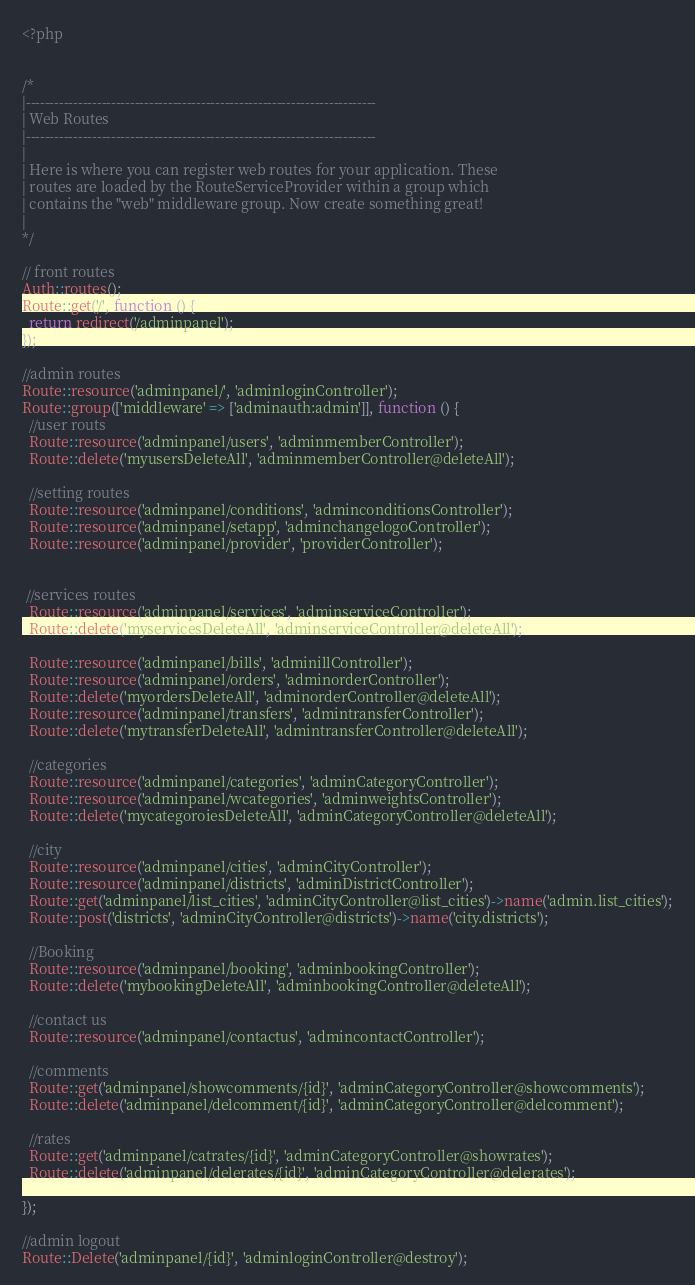<code> <loc_0><loc_0><loc_500><loc_500><_PHP_><?php


/*
|--------------------------------------------------------------------------
| Web Routes
|--------------------------------------------------------------------------
|
| Here is where you can register web routes for your application. These
| routes are loaded by the RouteServiceProvider within a group which
| contains the "web" middleware group. Now create something great!
|
*/

// front routes
Auth::routes();
Route::get('/', function () {
  return redirect('/adminpanel');
});

//admin routes
Route::resource('adminpanel/', 'adminloginController');
Route::group(['middleware' => ['adminauth:admin']], function () {
  //user routs
  Route::resource('adminpanel/users', 'adminmemberController');
  Route::delete('myusersDeleteAll', 'adminmemberController@deleteAll');

  //setting routes
  Route::resource('adminpanel/conditions', 'adminconditionsController');
  Route::resource('adminpanel/setapp', 'adminchangelogoController');
  Route::resource('adminpanel/provider', 'providerController');


 //services routes
  Route::resource('adminpanel/services', 'adminserviceController');
  Route::delete('myservicesDeleteAll', 'adminserviceController@deleteAll');

  Route::resource('adminpanel/bills', 'adminillController');
  Route::resource('adminpanel/orders', 'adminorderController');
  Route::delete('myordersDeleteAll', 'adminorderController@deleteAll');
  Route::resource('adminpanel/transfers', 'admintransferController');
  Route::delete('mytransferDeleteAll', 'admintransferController@deleteAll');

  //categories
  Route::resource('adminpanel/categories', 'adminCategoryController');
  Route::resource('adminpanel/wcategories', 'adminweightsController');
  Route::delete('mycategoroiesDeleteAll', 'adminCategoryController@deleteAll');

  //city
  Route::resource('adminpanel/cities', 'adminCityController');
  Route::resource('adminpanel/districts', 'adminDistrictController');
  Route::get('adminpanel/list_cities', 'adminCityController@list_cities')->name('admin.list_cities');
  Route::post('districts', 'adminCityController@districts')->name('city.districts');

  //Booking
  Route::resource('adminpanel/booking', 'adminbookingController');
  Route::delete('mybookingDeleteAll', 'adminbookingController@deleteAll');

  //contact us
  Route::resource('adminpanel/contactus', 'admincontactController');

  //comments
  Route::get('adminpanel/showcomments/{id}', 'adminCategoryController@showcomments');
  Route::delete('adminpanel/delcomment/{id}', 'adminCategoryController@delcomment');

  //rates
  Route::get('adminpanel/catrates/{id}', 'adminCategoryController@showrates');
  Route::delete('adminpanel/delerates/{id}', 'adminCategoryController@delerates');

});

//admin logout
Route::Delete('adminpanel/{id}', 'adminloginController@destroy');
</code> 